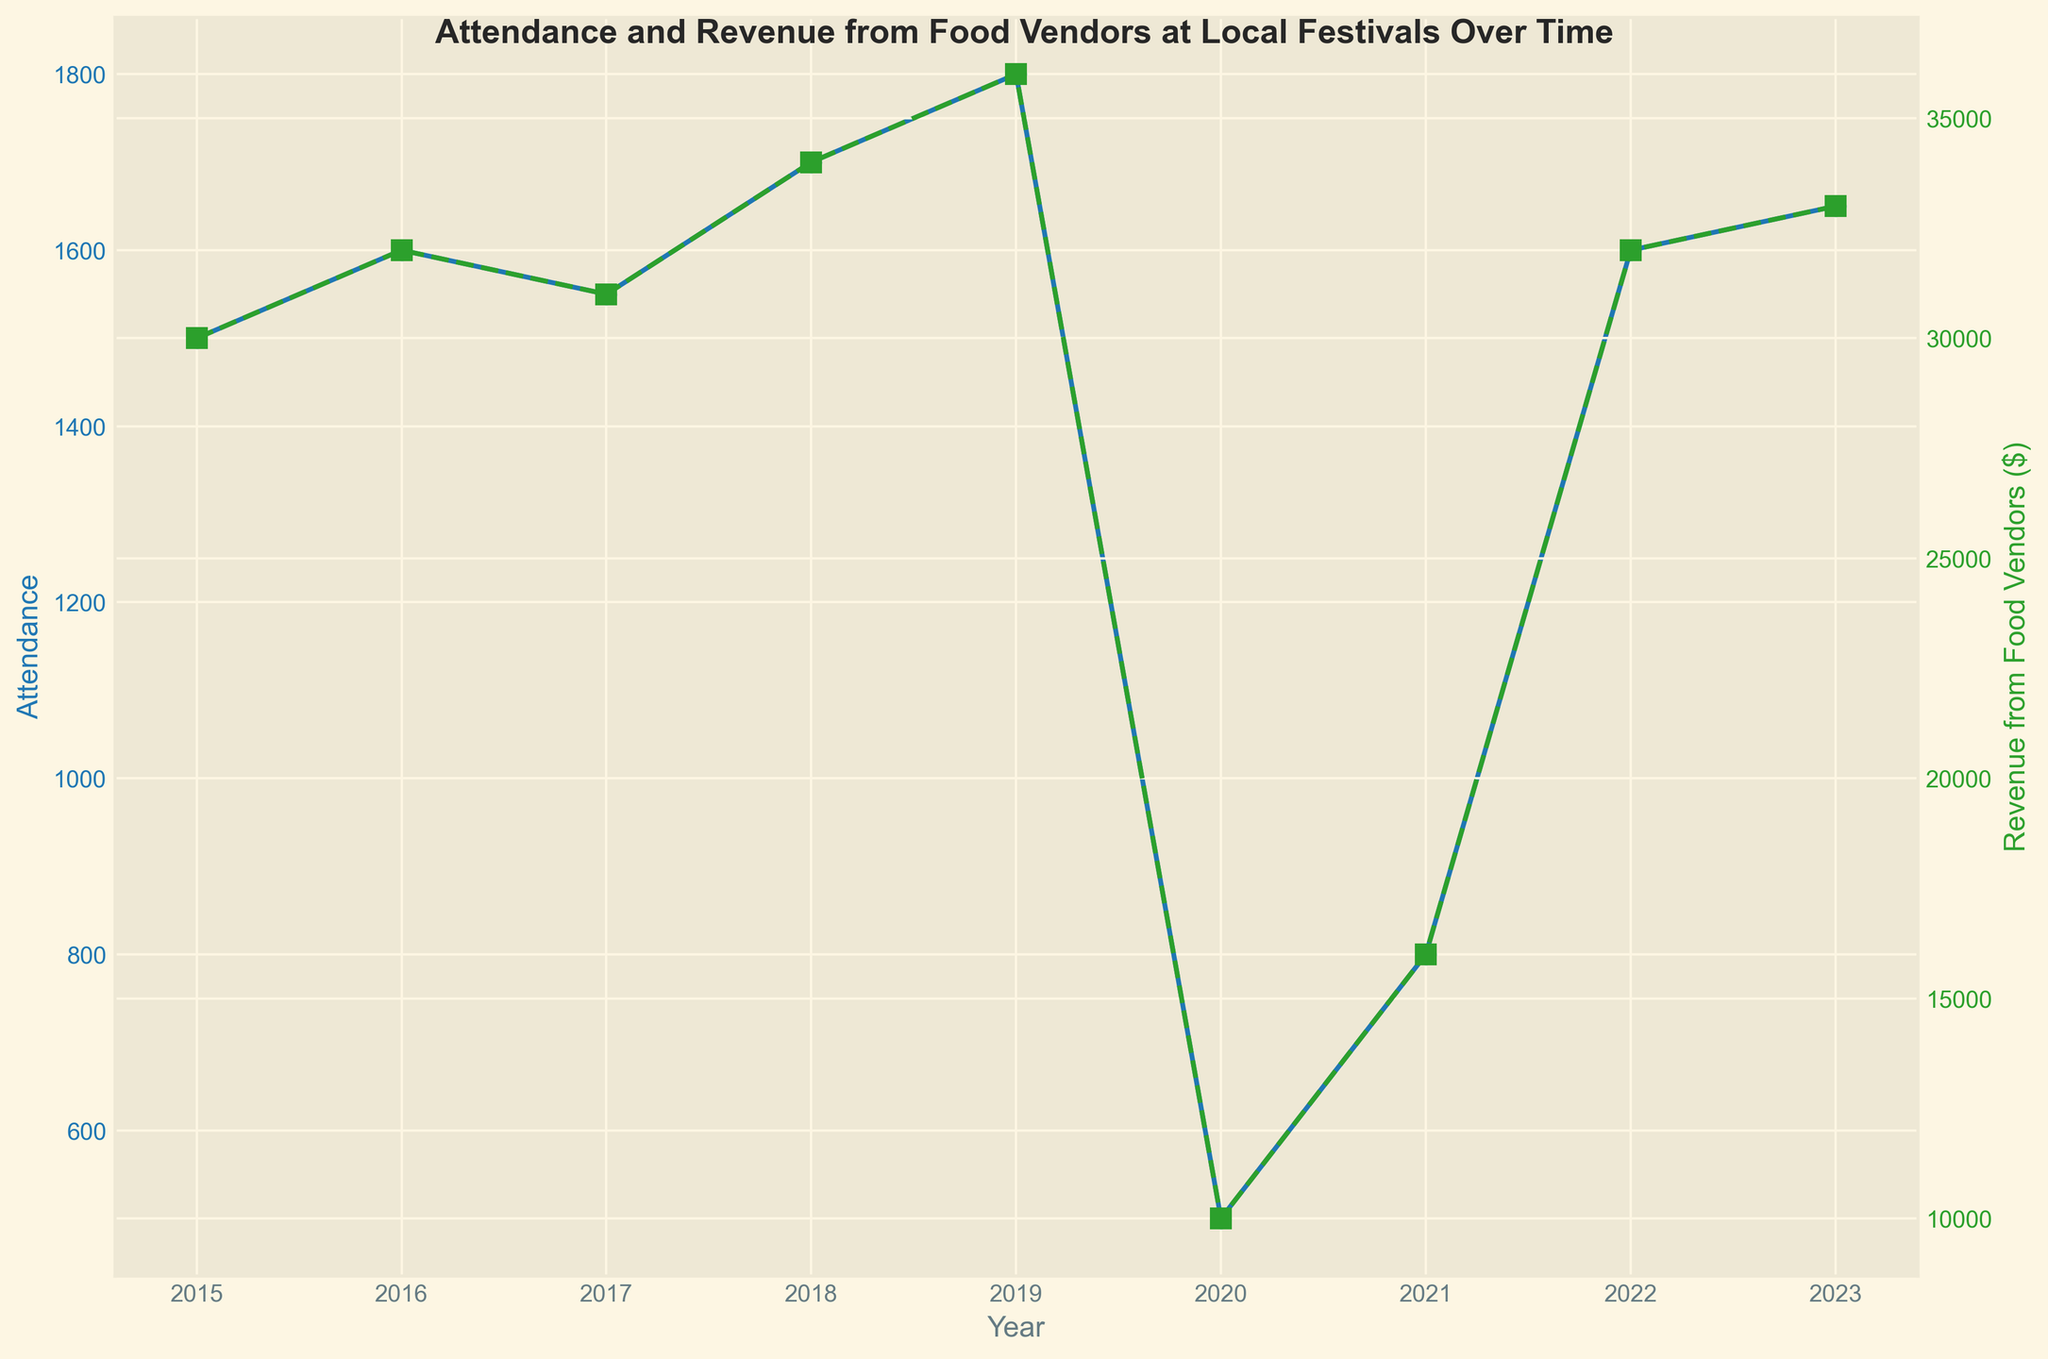What is the highest attendance recorded in the given years? The highest attendance can be observed by looking at the peak point on the blue line. The highest attendance is in 2019, which is 1800.
Answer: 1800 How much did the revenue from food vendors decrease from 2019 to 2020? By looking at the green line, we see the revenue in 2019 was $36,000 and in 2020 it was $10,000. So, the decrease is $36,000 - $10,000 = $26,000.
Answer: $26,000 In which year did the attendance see the most significant drop? Observing the blue line, the most significant drop in attendance is between 2019 and 2020, where it fell from 1800 to 500.
Answer: 2020 Compare the revenue from food vendors in 2016 and 2022. Which year had higher revenue? By comparing the heights of the green lines for 2016 and 2022, they both had the same revenue, which is $32,000.
Answer: Both years had equal revenue By how much did the attendance increase from 2020 to 2021? The attendance in 2020 was 500 and in 2021 it was 800. So, the increase is 800 - 500 = 300.
Answer: 300 Is there a year when both attendance and revenue from food vendors had the same relative trend (both increasing or both decreasing)? From 2017 to 2018, both the blue and green lines are increasing; attendance went from 1550 to 1700, and revenue went from $31,000 to $34,000.
Answer: Yes, from 2017 to 2018 Which year had a higher attendance: 2018 or 2023? By comparing the blue line markers for 2018 and 2023, the attendance in 2018 was 1700 and in 2023 it was 1650.
Answer: 2018 Identify the year with the lowest revenue from food vendors. The green line shows the lowest point in 2020, with a revenue of $10,000.
Answer: 2020 What is the average attendance from 2015 to 2023? Adding all attendance values: 1500 + 1600 + 1550 + 1700 + 1800 + 500 + 800 + 1600 + 1650 = 12200. Dividing by 9 (number of years): 12200 / 9 ≈ 1355.56.
Answer: 1356 (rounded) 